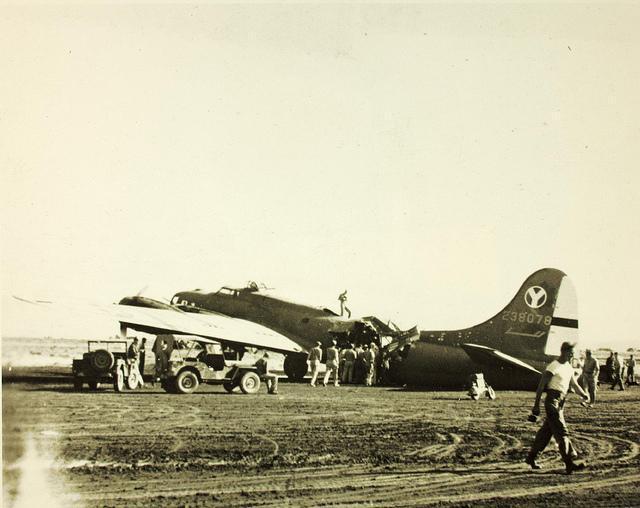How many trucks are in the picture?
Give a very brief answer. 2. 